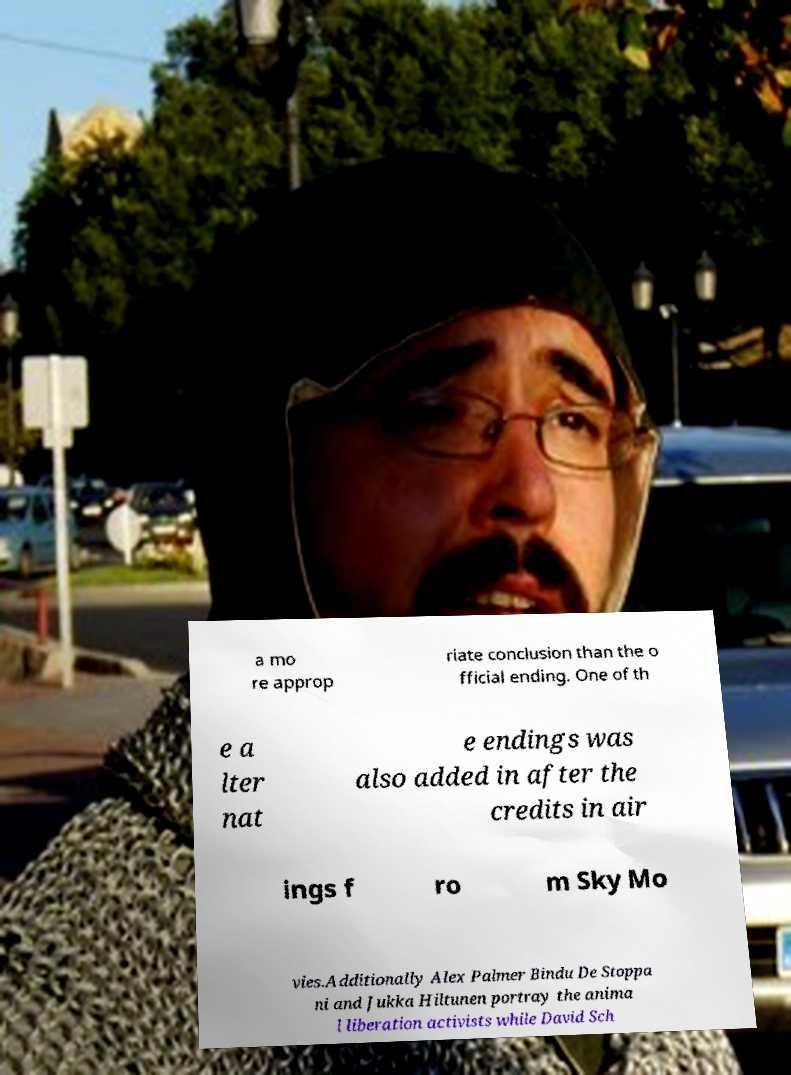Can you read and provide the text displayed in the image?This photo seems to have some interesting text. Can you extract and type it out for me? a mo re approp riate conclusion than the o fficial ending. One of th e a lter nat e endings was also added in after the credits in air ings f ro m Sky Mo vies.Additionally Alex Palmer Bindu De Stoppa ni and Jukka Hiltunen portray the anima l liberation activists while David Sch 